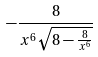Convert formula to latex. <formula><loc_0><loc_0><loc_500><loc_500>- \frac { 8 } { x ^ { 6 } \sqrt { 8 - \frac { 8 } { x ^ { 6 } } } }</formula> 